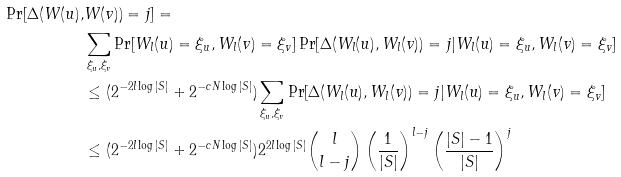<formula> <loc_0><loc_0><loc_500><loc_500>\Pr [ \Delta ( W ( u ) , & W ( v ) ) = j ] = \\ & \sum _ { \xi _ { u } , \xi _ { v } } \Pr [ W _ { l } ( u ) = \xi _ { u } , W _ { l } ( v ) = \xi _ { v } ] \Pr [ \Delta ( W _ { l } ( u ) , W _ { l } ( v ) ) = j | W _ { l } ( u ) = \xi _ { u } , W _ { l } ( v ) = \xi _ { v } ] \\ & \leq ( 2 ^ { - 2 l \log | S | } + 2 ^ { - c N \log | S | } ) \sum _ { \xi _ { u } , \xi _ { v } } \Pr [ \Delta ( W _ { l } ( u ) , W _ { l } ( v ) ) = j | W _ { l } ( u ) = \xi _ { u } , W _ { l } ( v ) = \xi _ { v } ] \\ & \leq ( 2 ^ { - 2 l \log | S | } + 2 ^ { - c N \log | S | } ) 2 ^ { 2 l \log | S | } { l \choose l - j } \left ( \frac { 1 } { | S | } \right ) ^ { l - j } \left ( \frac { | S | - 1 } { | S | } \right ) ^ { j }</formula> 